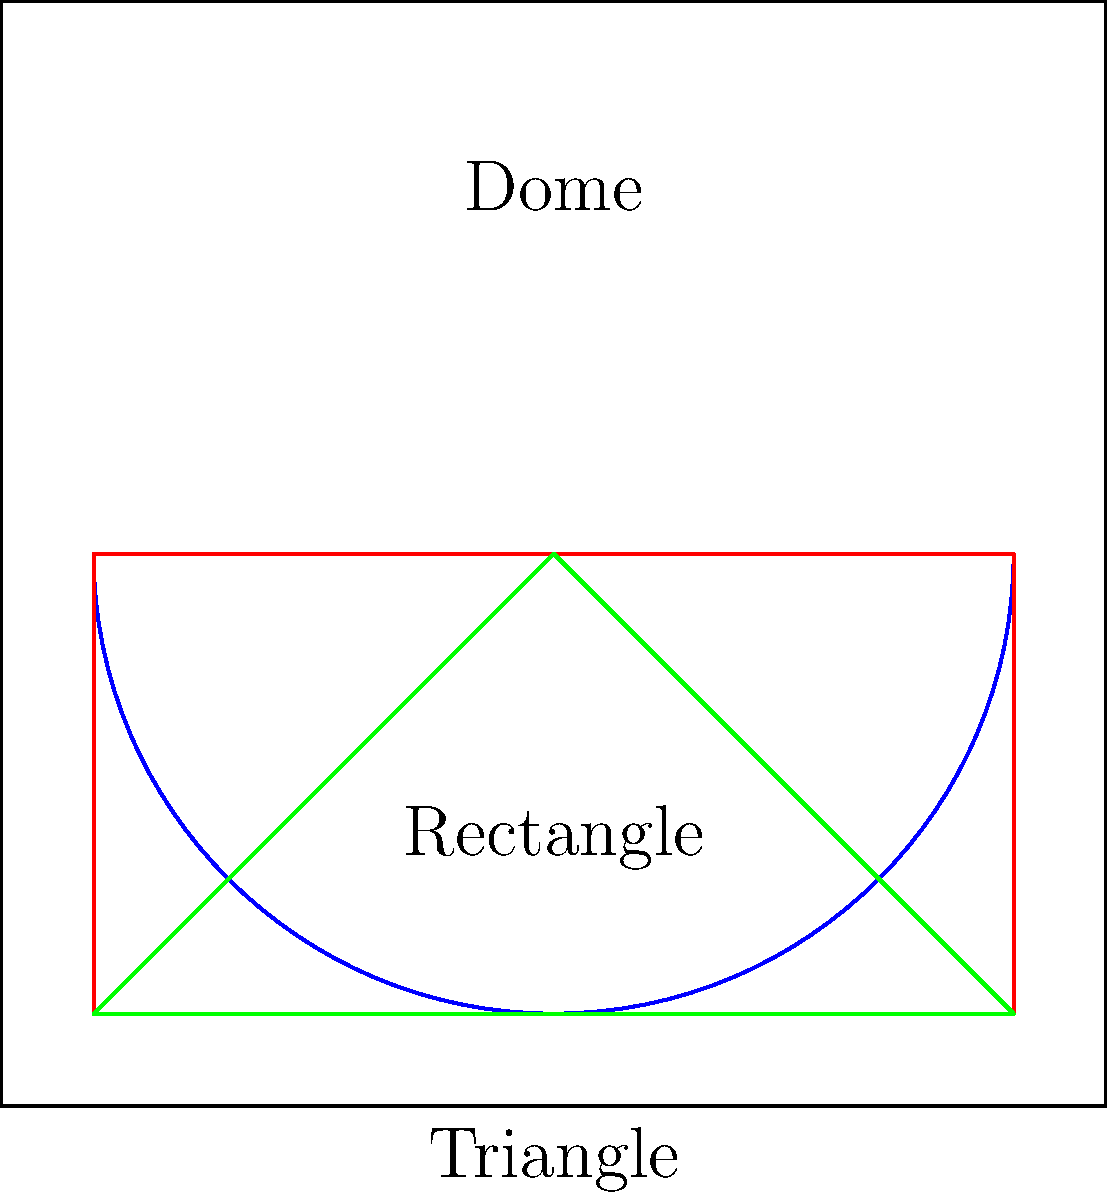Considering the acoustic properties of different prayer hall shapes, which shape would generally provide the best sound distribution for the Imam's voice during prayer? To understand the acoustic properties of different prayer hall shapes, we need to consider how sound waves behave in each shape:

1. Dome shape:
   - Focuses sound waves towards the center
   - Can create echoes and sound concentration in specific areas
   - May cause sound distortion in some parts of the hall

2. Rectangular shape:
   - Provides more even sound distribution
   - Allows for better control of reverberation time
   - Minimizes echoes and sound focusing

3. Triangular shape:
   - Can create uneven sound distribution
   - May cause sound to concentrate at specific points
   - Can lead to echoes and sound distortion

The rectangular shape generally provides the best sound distribution for the following reasons:

a) Even sound distribution: The parallel walls in a rectangular space help distribute sound waves more evenly throughout the prayer hall.

b) Controlled reverberation: Rectangular spaces allow for easier management of reverberation time, which is crucial for speech clarity.

c) Minimal sound focusing: Unlike domes or triangular shapes, rectangles are less likely to create focal points where sound concentrates excessively.

d) Flexibility: Rectangular spaces can be easily modified with acoustic treatments to further improve sound quality if needed.

While domes are often used in mosque architecture for their aesthetic and symbolic value, they can present acoustic challenges. Triangular shapes are less common and generally not preferred for acoustic reasons.
Answer: Rectangular shape 